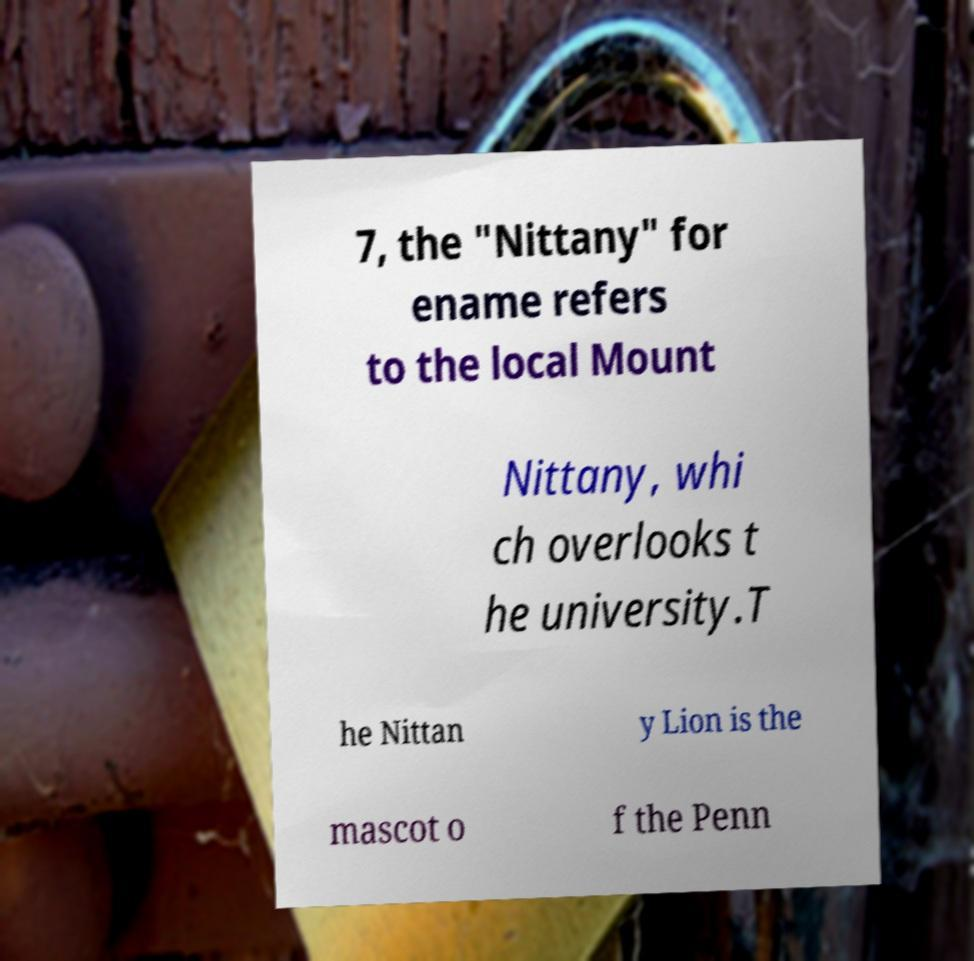There's text embedded in this image that I need extracted. Can you transcribe it verbatim? 7, the "Nittany" for ename refers to the local Mount Nittany, whi ch overlooks t he university.T he Nittan y Lion is the mascot o f the Penn 